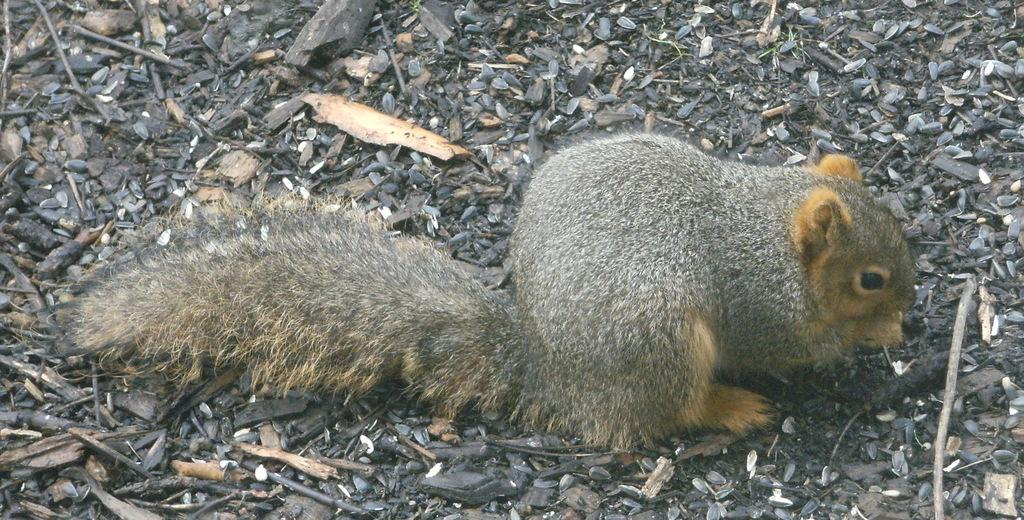What type of animal can be seen in the image? There is a squirrel in the image. What is the squirrel interacting with in the image? The squirrel is interacting with seeds in the image. What type of objects are made of wood in the image? There are wooden objects in the image. What type of drink is the squirrel holding in the image? There is no drink present in the image; the squirrel is interacting with seeds. 